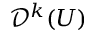<formula> <loc_0><loc_0><loc_500><loc_500>{ \mathcal { D } } ^ { k } ( U )</formula> 